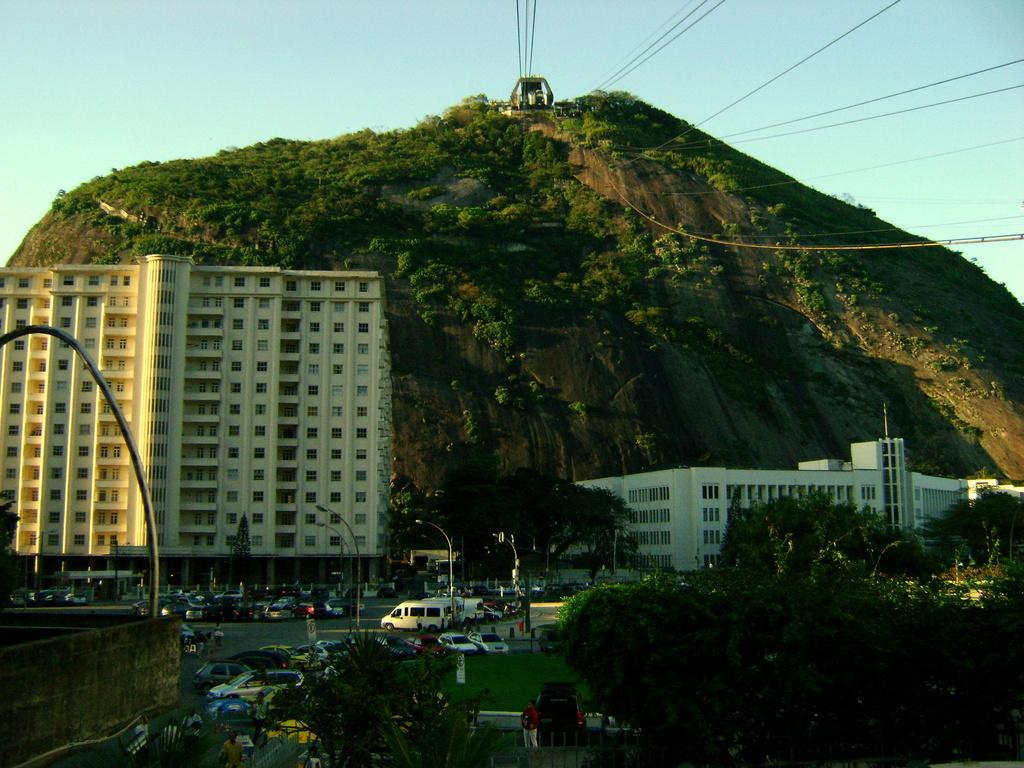What can be seen in the foreground of the image? In the foreground of the image, there are trees, poles, vehicles on the road, a cliff, and an electric cable car. Can you describe the type of trees in the foreground? The facts provided do not specify the type of trees, so we cannot describe them. What is the purpose of the poles in the foreground? The purpose of the poles is not mentioned in the facts, so we cannot determine their purpose. What is the location of the vehicles in the image? The vehicles are on the road in the foreground of the image. What is the electric cable car used for? The electric cable car is likely used for transportation, as it is a common mode of transportation in areas with steep terrain. What type of card is being used to mark the location of the cliff in the image? There is no card present in the image, and the location of the cliff is already clearly visible. 